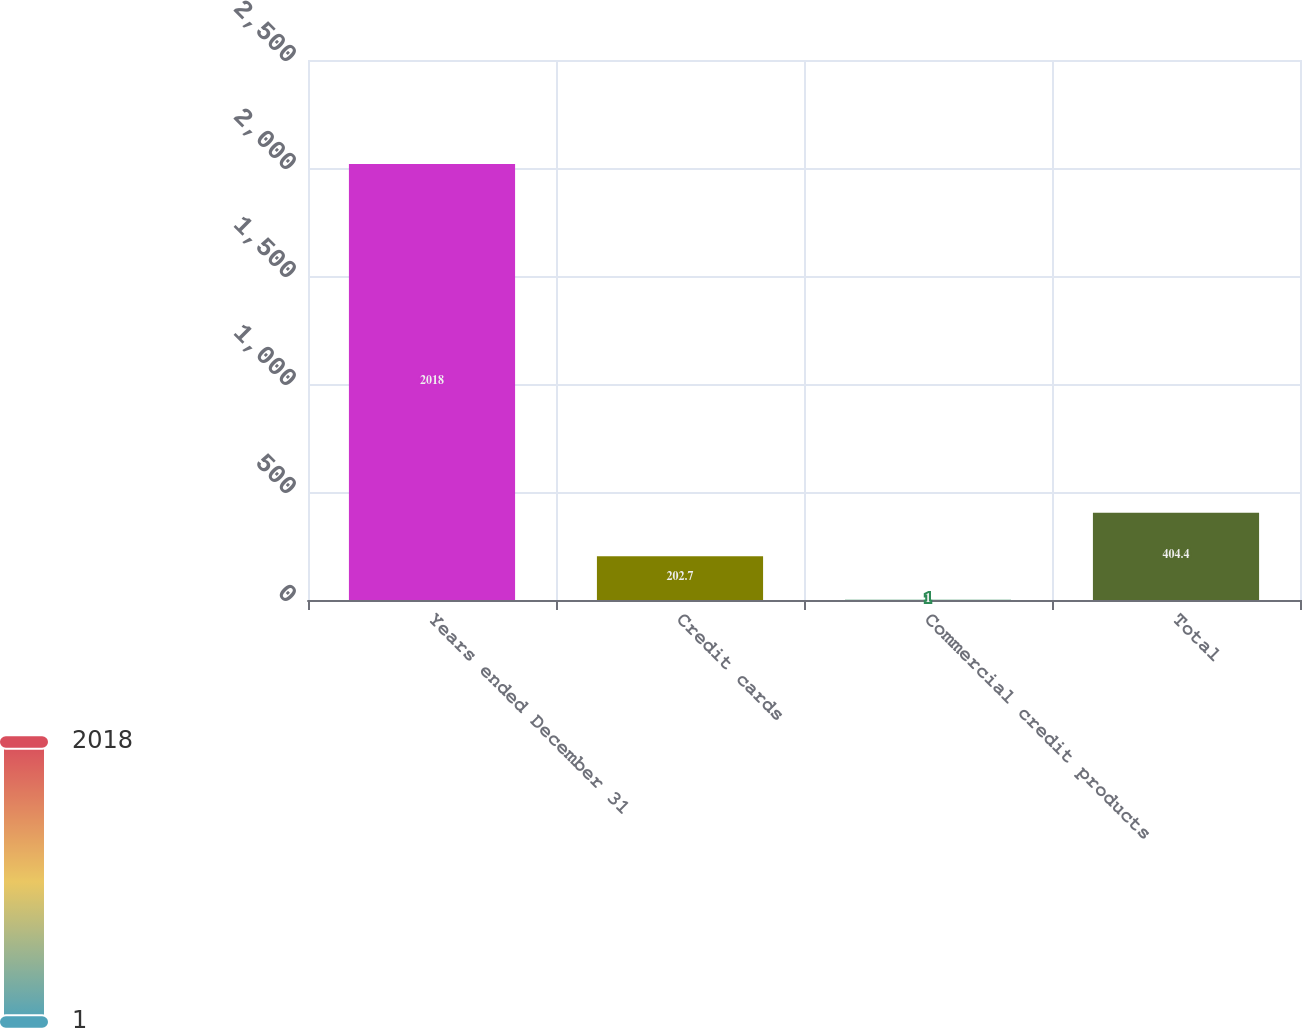Convert chart to OTSL. <chart><loc_0><loc_0><loc_500><loc_500><bar_chart><fcel>Years ended December 31<fcel>Credit cards<fcel>Commercial credit products<fcel>Total<nl><fcel>2018<fcel>202.7<fcel>1<fcel>404.4<nl></chart> 